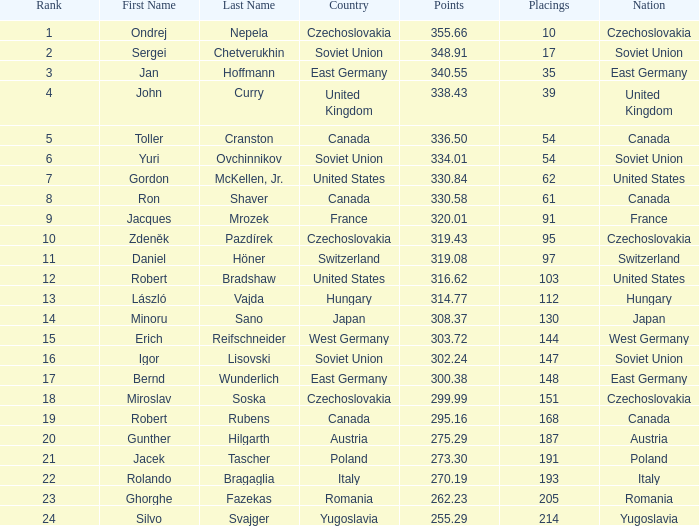How many placings have points less than 330.84 and a name of silvo svajger? 1.0. 